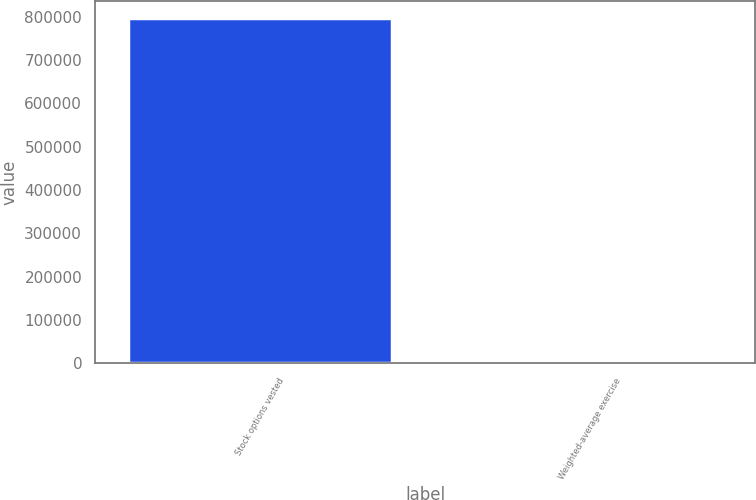Convert chart. <chart><loc_0><loc_0><loc_500><loc_500><bar_chart><fcel>Stock options vested<fcel>Weighted-average exercise<nl><fcel>795566<fcel>46.86<nl></chart> 